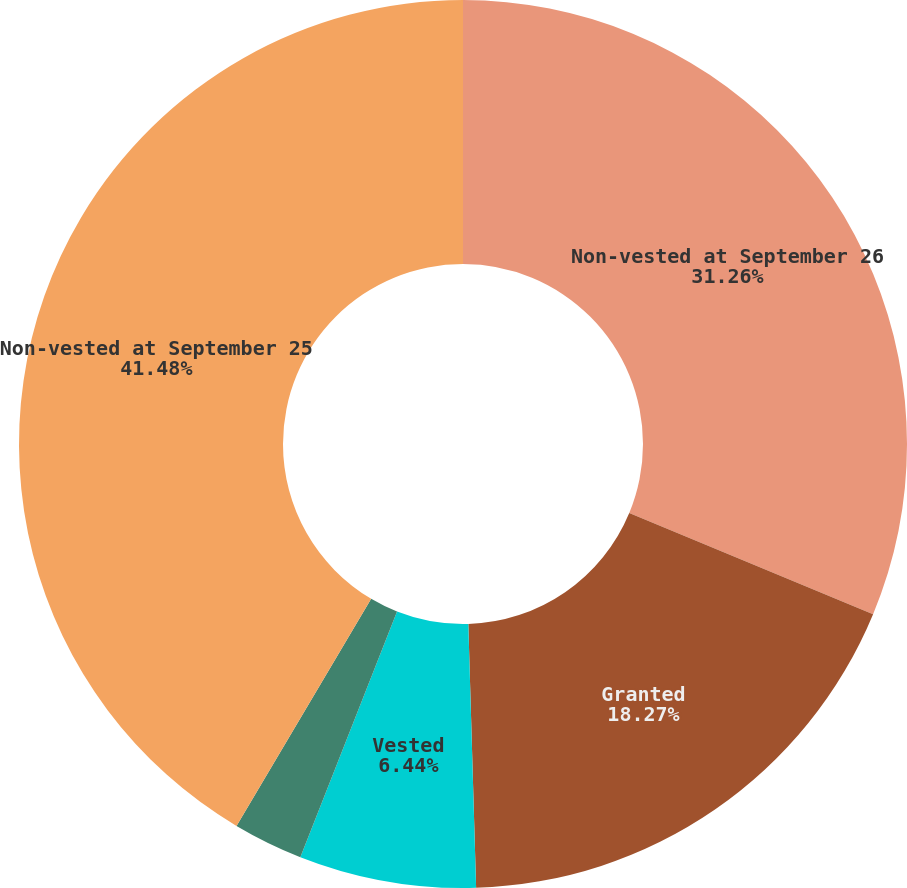<chart> <loc_0><loc_0><loc_500><loc_500><pie_chart><fcel>Non-vested at September 26<fcel>Granted<fcel>Vested<fcel>Forfeited<fcel>Non-vested at September 25<nl><fcel>31.26%<fcel>18.27%<fcel>6.44%<fcel>2.55%<fcel>41.48%<nl></chart> 